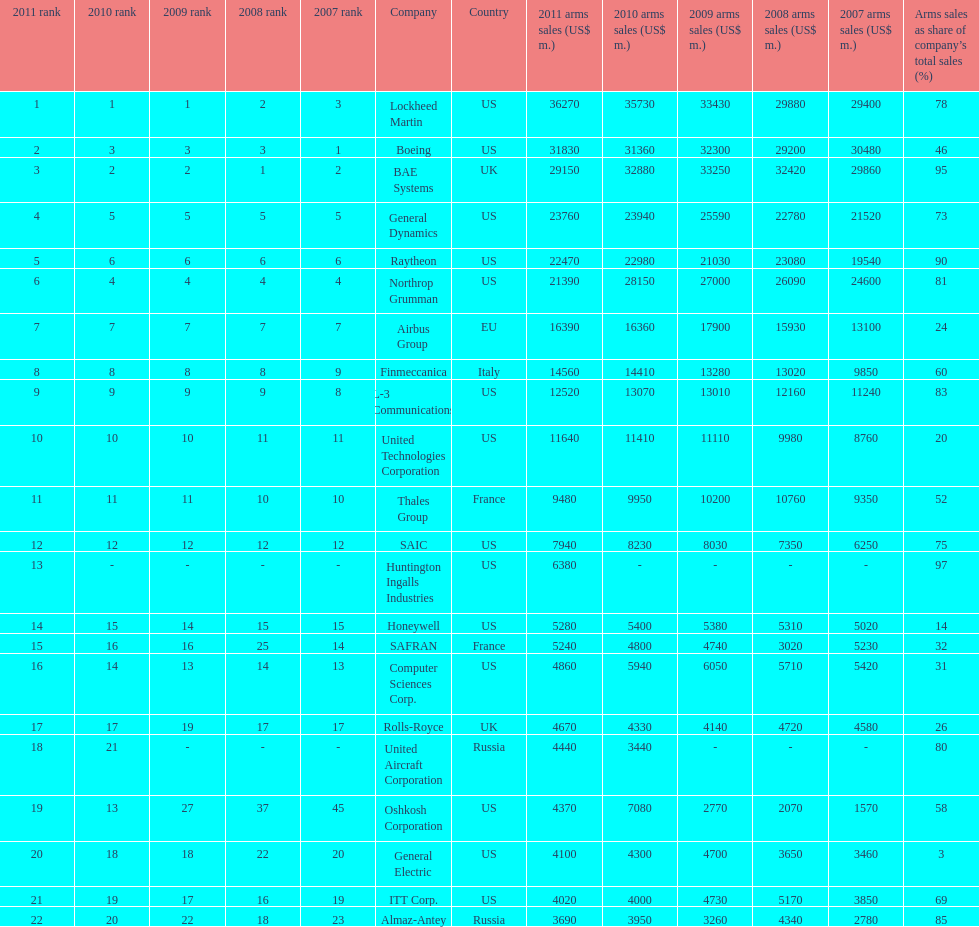Which company had the highest 2009 arms sales? Lockheed Martin. 